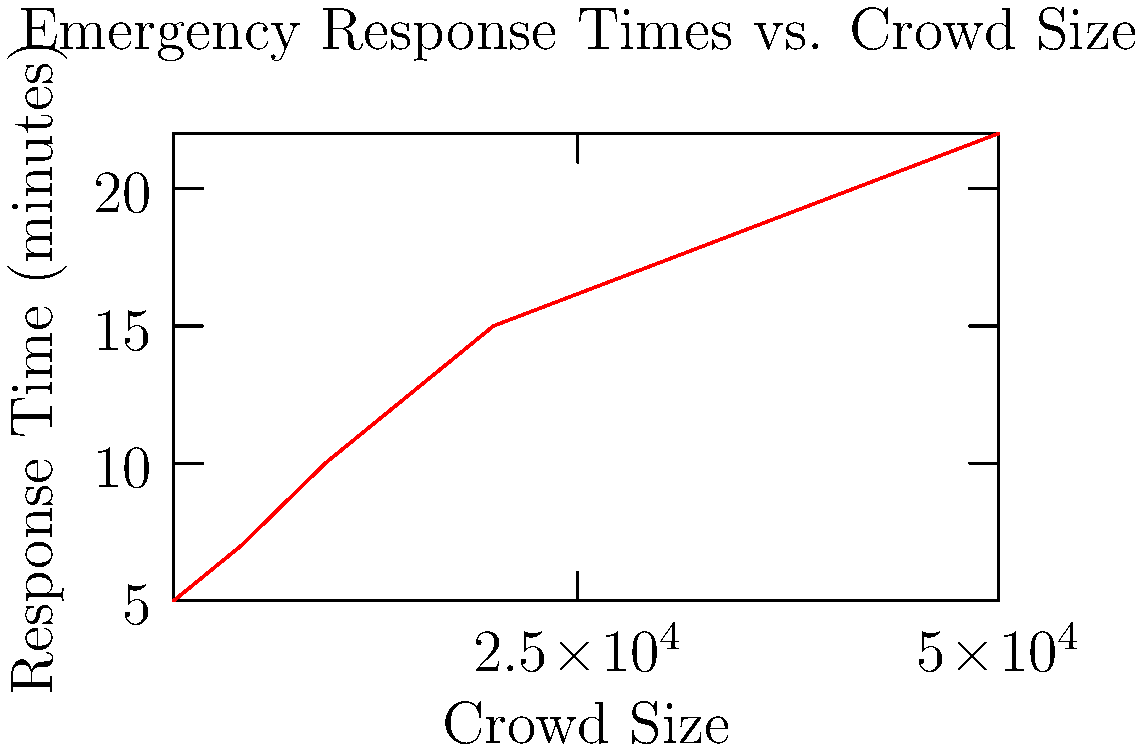Based on the graph showing emergency response times at different crowd sizes, what is the approximate rate of increase in response time (in minutes) for every additional 10,000 people in the crowd between 10,000 and 50,000 attendees? To solve this problem, we need to follow these steps:

1. Identify the response times for crowd sizes of 10,000 and 50,000:
   - At 10,000 people: 10 minutes
   - At 50,000 people: 22 minutes

2. Calculate the total increase in response time:
   $22 - 10 = 12$ minutes

3. Calculate the total increase in crowd size:
   $50,000 - 10,000 = 40,000$ people

4. Calculate the rate of increase per 10,000 people:
   $\frac{12 \text{ minutes}}{40,000 \text{ people}} \times 10,000 \text{ people} = 3 \text{ minutes per 10,000 people}$

Therefore, the approximate rate of increase in response time is 3 minutes for every additional 10,000 people in the crowd between 10,000 and 50,000 attendees.
Answer: 3 minutes per 10,000 people 